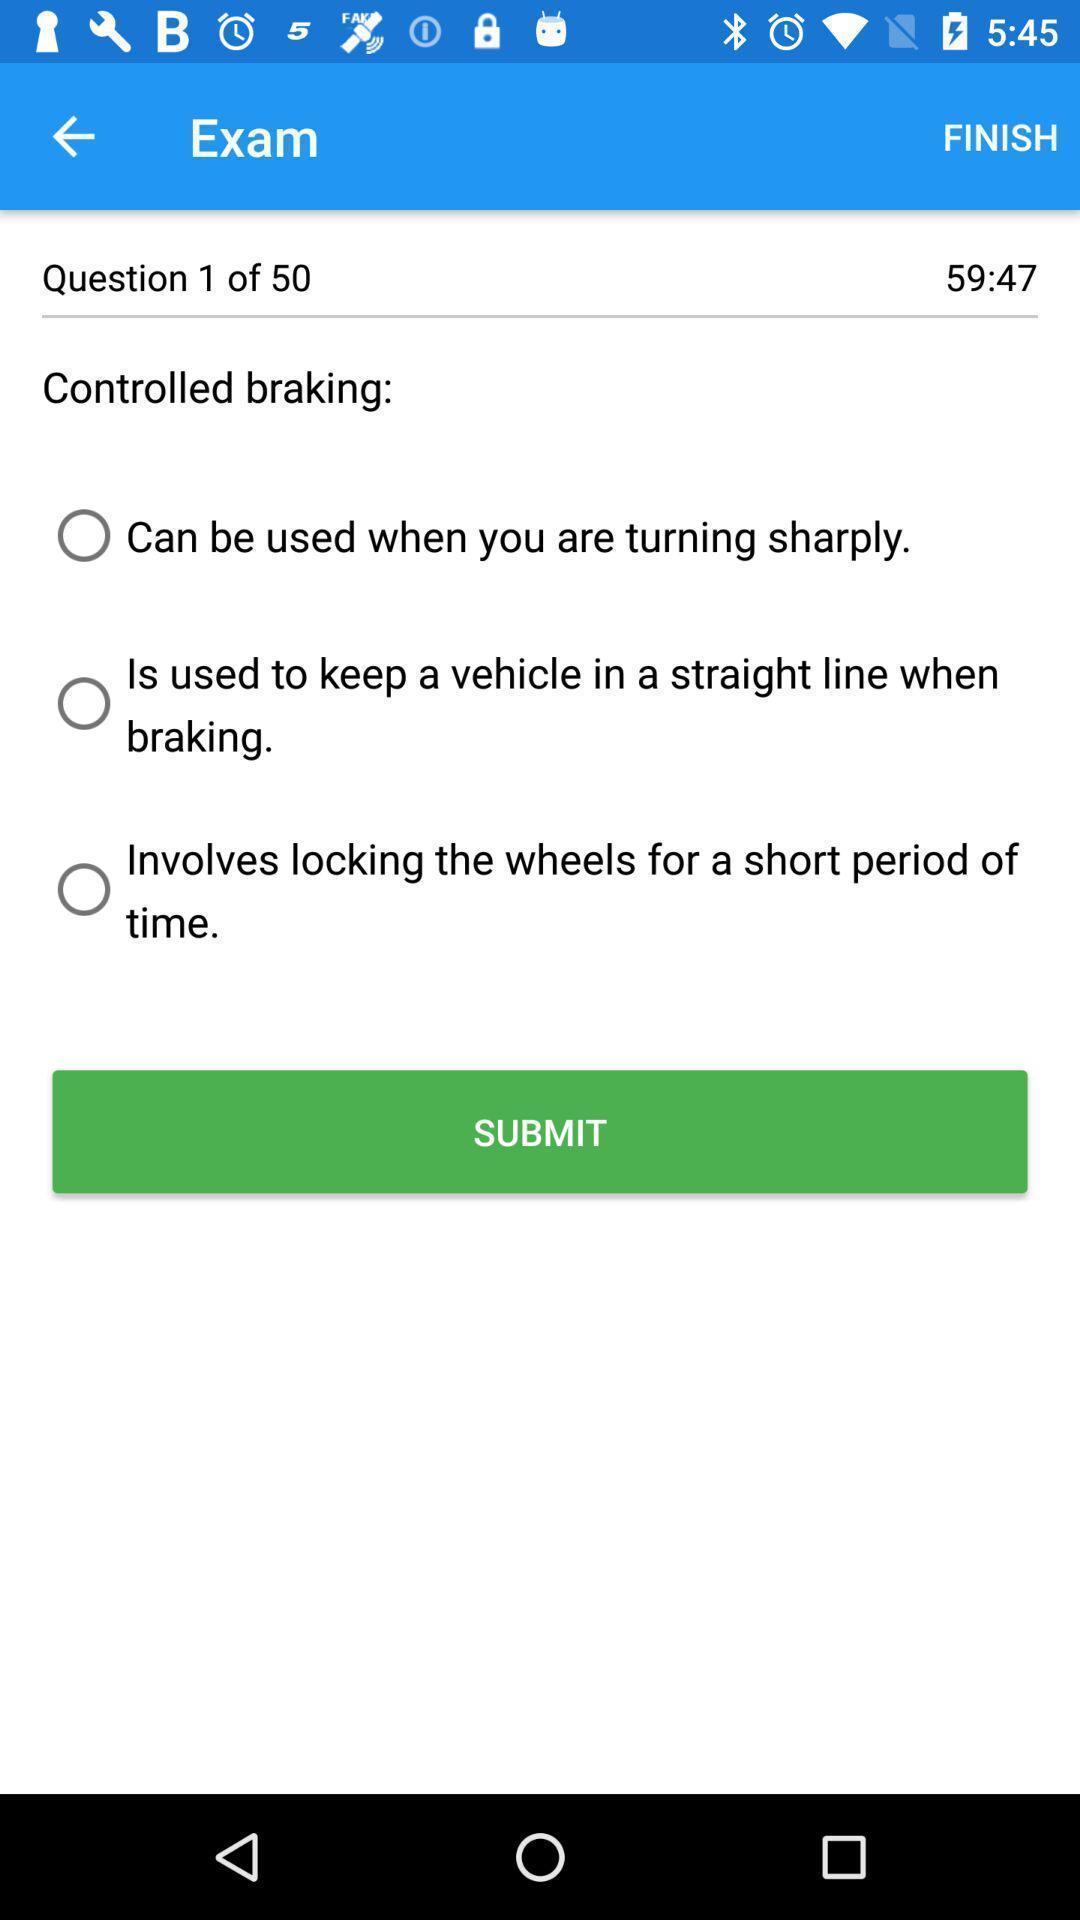Give me a summary of this screen capture. Page showing option like submit. 